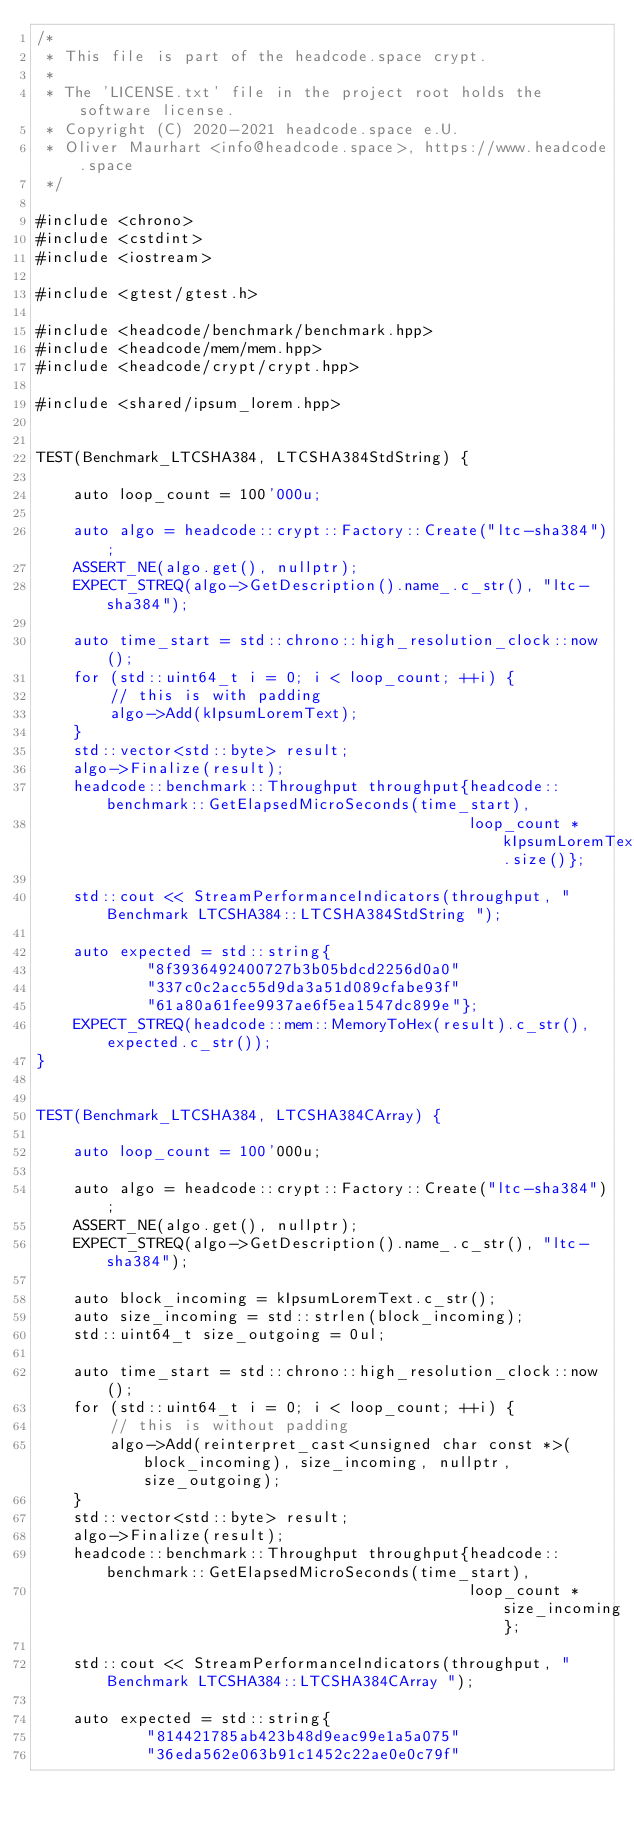<code> <loc_0><loc_0><loc_500><loc_500><_C++_>/*
 * This file is part of the headcode.space crypt.
 *
 * The 'LICENSE.txt' file in the project root holds the software license.
 * Copyright (C) 2020-2021 headcode.space e.U.
 * Oliver Maurhart <info@headcode.space>, https://www.headcode.space
 */

#include <chrono>
#include <cstdint>
#include <iostream>

#include <gtest/gtest.h>

#include <headcode/benchmark/benchmark.hpp>
#include <headcode/mem/mem.hpp>
#include <headcode/crypt/crypt.hpp>

#include <shared/ipsum_lorem.hpp>


TEST(Benchmark_LTCSHA384, LTCSHA384StdString) {

    auto loop_count = 100'000u;

    auto algo = headcode::crypt::Factory::Create("ltc-sha384");
    ASSERT_NE(algo.get(), nullptr);
    EXPECT_STREQ(algo->GetDescription().name_.c_str(), "ltc-sha384");

    auto time_start = std::chrono::high_resolution_clock::now();
    for (std::uint64_t i = 0; i < loop_count; ++i) {
        // this is with padding
        algo->Add(kIpsumLoremText);
    }
    std::vector<std::byte> result;
    algo->Finalize(result);
    headcode::benchmark::Throughput throughput{headcode::benchmark::GetElapsedMicroSeconds(time_start),
                                               loop_count * kIpsumLoremText.size()};

    std::cout << StreamPerformanceIndicators(throughput, "Benchmark LTCSHA384::LTCSHA384StdString ");

    auto expected = std::string{
            "8f3936492400727b3b05bdcd2256d0a0"
            "337c0c2acc55d9da3a51d089cfabe93f"
            "61a80a61fee9937ae6f5ea1547dc899e"};
    EXPECT_STREQ(headcode::mem::MemoryToHex(result).c_str(), expected.c_str());
}


TEST(Benchmark_LTCSHA384, LTCSHA384CArray) {

    auto loop_count = 100'000u;

    auto algo = headcode::crypt::Factory::Create("ltc-sha384");
    ASSERT_NE(algo.get(), nullptr);
    EXPECT_STREQ(algo->GetDescription().name_.c_str(), "ltc-sha384");

    auto block_incoming = kIpsumLoremText.c_str();
    auto size_incoming = std::strlen(block_incoming);
    std::uint64_t size_outgoing = 0ul;

    auto time_start = std::chrono::high_resolution_clock::now();
    for (std::uint64_t i = 0; i < loop_count; ++i) {
        // this is without padding
        algo->Add(reinterpret_cast<unsigned char const *>(block_incoming), size_incoming, nullptr, size_outgoing);
    }
    std::vector<std::byte> result;
    algo->Finalize(result);
    headcode::benchmark::Throughput throughput{headcode::benchmark::GetElapsedMicroSeconds(time_start),
                                               loop_count * size_incoming};

    std::cout << StreamPerformanceIndicators(throughput, "Benchmark LTCSHA384::LTCSHA384CArray ");

    auto expected = std::string{
            "814421785ab423b48d9eac99e1a5a075"
            "36eda562e063b91c1452c22ae0e0c79f"</code> 